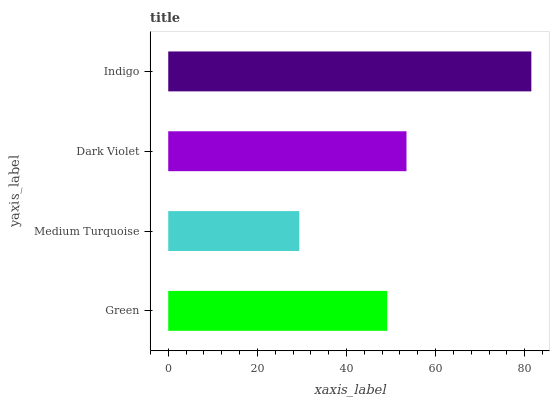Is Medium Turquoise the minimum?
Answer yes or no. Yes. Is Indigo the maximum?
Answer yes or no. Yes. Is Dark Violet the minimum?
Answer yes or no. No. Is Dark Violet the maximum?
Answer yes or no. No. Is Dark Violet greater than Medium Turquoise?
Answer yes or no. Yes. Is Medium Turquoise less than Dark Violet?
Answer yes or no. Yes. Is Medium Turquoise greater than Dark Violet?
Answer yes or no. No. Is Dark Violet less than Medium Turquoise?
Answer yes or no. No. Is Dark Violet the high median?
Answer yes or no. Yes. Is Green the low median?
Answer yes or no. Yes. Is Green the high median?
Answer yes or no. No. Is Dark Violet the low median?
Answer yes or no. No. 